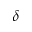<formula> <loc_0><loc_0><loc_500><loc_500>\delta</formula> 